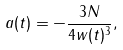<formula> <loc_0><loc_0><loc_500><loc_500>a ( t ) = - \frac { 3 N } { 4 w ( t ) ^ { 3 } } ,</formula> 